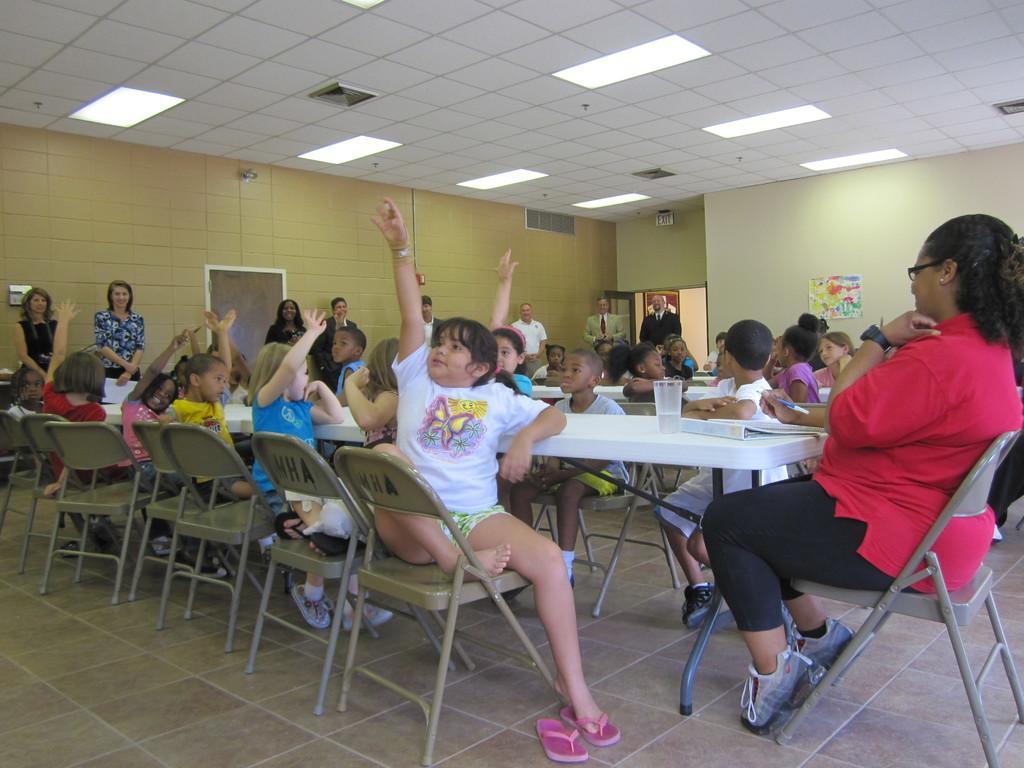Can you describe this image briefly? There are many children sitting in front of a table in the chairs in a dining hall. Some of them are raising hands. In the background we can observe two women standing near the wall. 